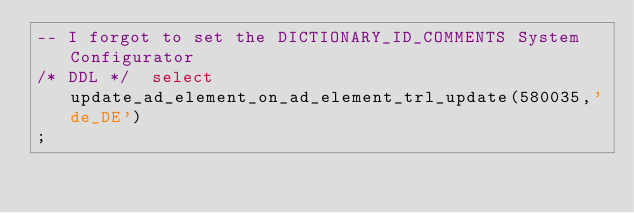Convert code to text. <code><loc_0><loc_0><loc_500><loc_500><_SQL_>-- I forgot to set the DICTIONARY_ID_COMMENTS System Configurator
/* DDL */  select update_ad_element_on_ad_element_trl_update(580035,'de_DE') 
;
</code> 